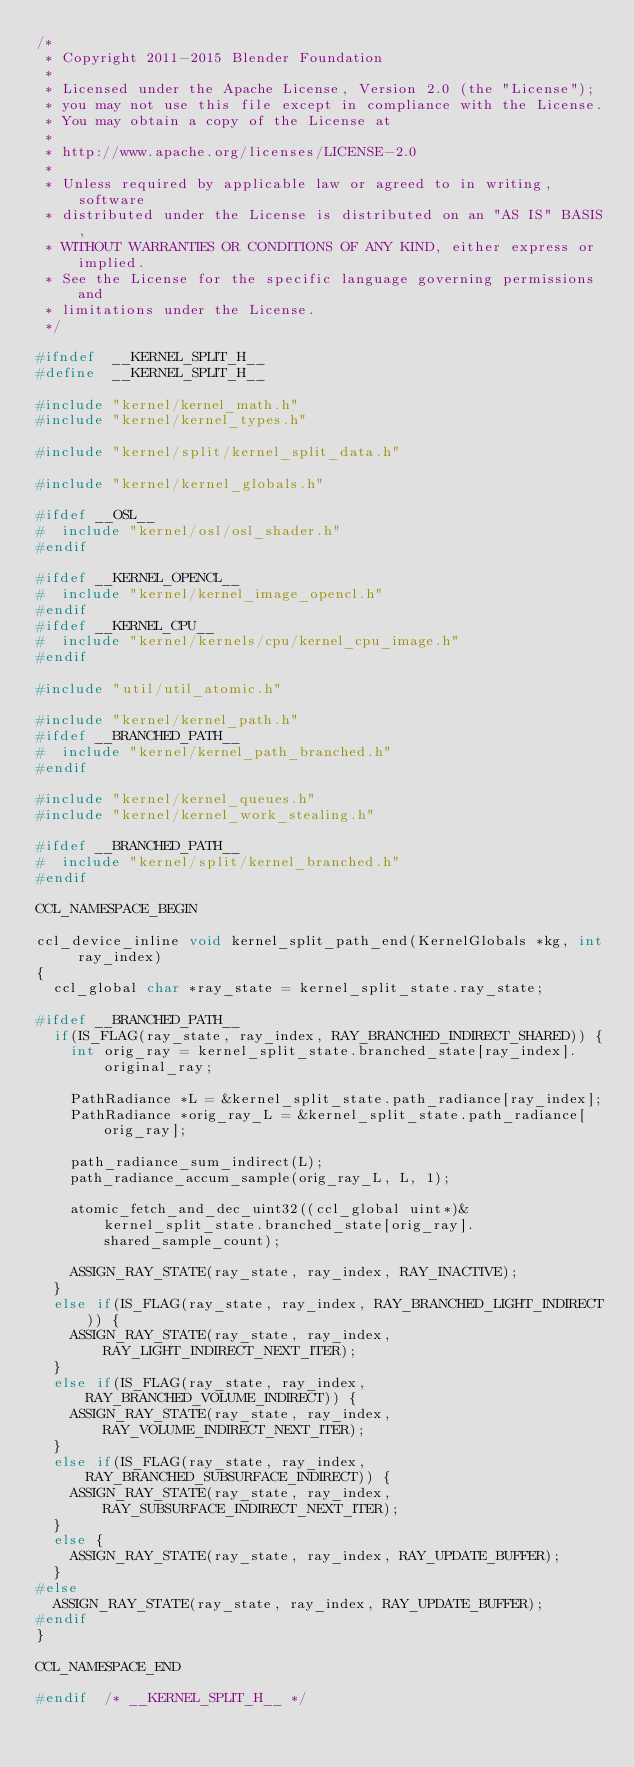Convert code to text. <code><loc_0><loc_0><loc_500><loc_500><_C_>/*
 * Copyright 2011-2015 Blender Foundation
 *
 * Licensed under the Apache License, Version 2.0 (the "License");
 * you may not use this file except in compliance with the License.
 * You may obtain a copy of the License at
 *
 * http://www.apache.org/licenses/LICENSE-2.0
 *
 * Unless required by applicable law or agreed to in writing, software
 * distributed under the License is distributed on an "AS IS" BASIS,
 * WITHOUT WARRANTIES OR CONDITIONS OF ANY KIND, either express or implied.
 * See the License for the specific language governing permissions and
 * limitations under the License.
 */

#ifndef  __KERNEL_SPLIT_H__
#define  __KERNEL_SPLIT_H__

#include "kernel/kernel_math.h"
#include "kernel/kernel_types.h"

#include "kernel/split/kernel_split_data.h"

#include "kernel/kernel_globals.h"

#ifdef __OSL__
#  include "kernel/osl/osl_shader.h"
#endif

#ifdef __KERNEL_OPENCL__
#  include "kernel/kernel_image_opencl.h"
#endif
#ifdef __KERNEL_CPU__
#  include "kernel/kernels/cpu/kernel_cpu_image.h"
#endif

#include "util/util_atomic.h"

#include "kernel/kernel_path.h"
#ifdef __BRANCHED_PATH__
#  include "kernel/kernel_path_branched.h"
#endif

#include "kernel/kernel_queues.h"
#include "kernel/kernel_work_stealing.h"

#ifdef __BRANCHED_PATH__
#  include "kernel/split/kernel_branched.h"
#endif

CCL_NAMESPACE_BEGIN

ccl_device_inline void kernel_split_path_end(KernelGlobals *kg, int ray_index)
{
	ccl_global char *ray_state = kernel_split_state.ray_state;

#ifdef __BRANCHED_PATH__
	if(IS_FLAG(ray_state, ray_index, RAY_BRANCHED_INDIRECT_SHARED)) {
		int orig_ray = kernel_split_state.branched_state[ray_index].original_ray;

		PathRadiance *L = &kernel_split_state.path_radiance[ray_index];
		PathRadiance *orig_ray_L = &kernel_split_state.path_radiance[orig_ray];

		path_radiance_sum_indirect(L);
		path_radiance_accum_sample(orig_ray_L, L, 1);

		atomic_fetch_and_dec_uint32((ccl_global uint*)&kernel_split_state.branched_state[orig_ray].shared_sample_count);

		ASSIGN_RAY_STATE(ray_state, ray_index, RAY_INACTIVE);
	}
	else if(IS_FLAG(ray_state, ray_index, RAY_BRANCHED_LIGHT_INDIRECT)) {
		ASSIGN_RAY_STATE(ray_state, ray_index, RAY_LIGHT_INDIRECT_NEXT_ITER);
	}
	else if(IS_FLAG(ray_state, ray_index, RAY_BRANCHED_VOLUME_INDIRECT)) {
		ASSIGN_RAY_STATE(ray_state, ray_index, RAY_VOLUME_INDIRECT_NEXT_ITER);
	}
	else if(IS_FLAG(ray_state, ray_index, RAY_BRANCHED_SUBSURFACE_INDIRECT)) {
		ASSIGN_RAY_STATE(ray_state, ray_index, RAY_SUBSURFACE_INDIRECT_NEXT_ITER);
	}
	else {
		ASSIGN_RAY_STATE(ray_state, ray_index, RAY_UPDATE_BUFFER);
	}
#else
	ASSIGN_RAY_STATE(ray_state, ray_index, RAY_UPDATE_BUFFER);
#endif
}

CCL_NAMESPACE_END

#endif  /* __KERNEL_SPLIT_H__ */
</code> 